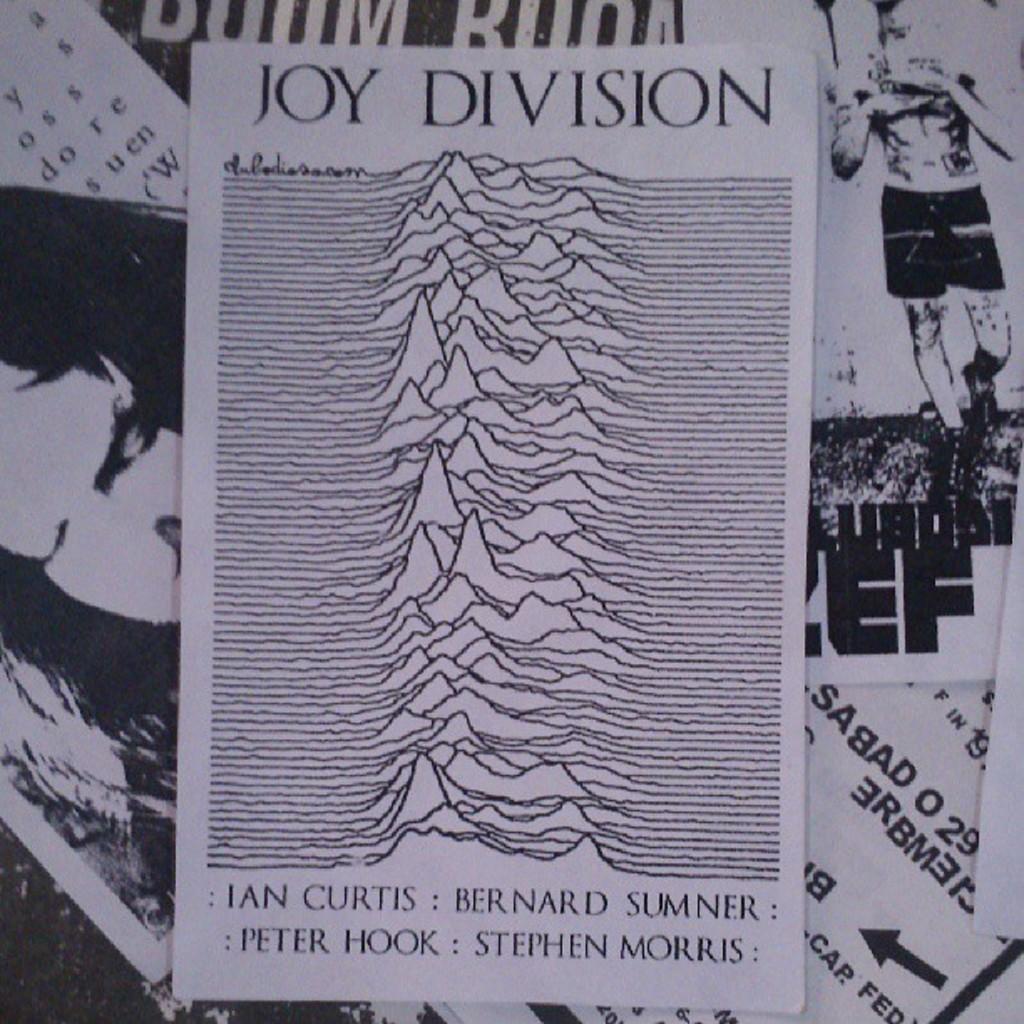Who are the members of joy division?
Give a very brief answer. Ian curtis, bernard sumner, peter hook, stephen morris. What band is listed on the image?
Make the answer very short. Joy division. 